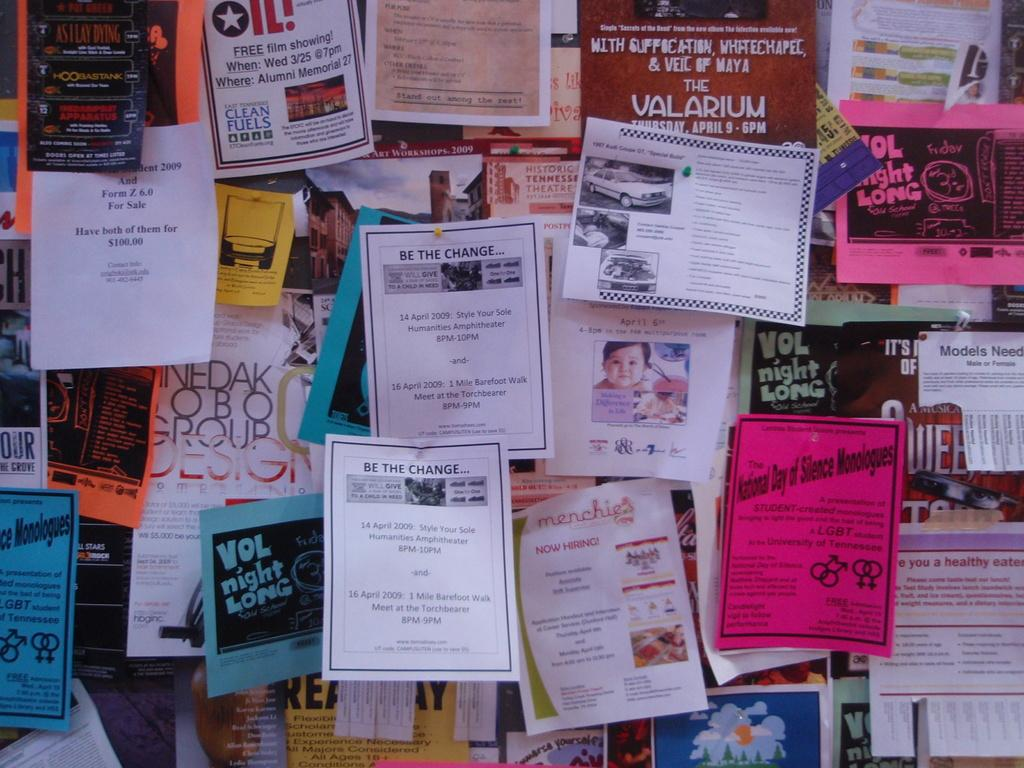<image>
Provide a brief description of the given image. The white paper in the middle says be the change on the top 